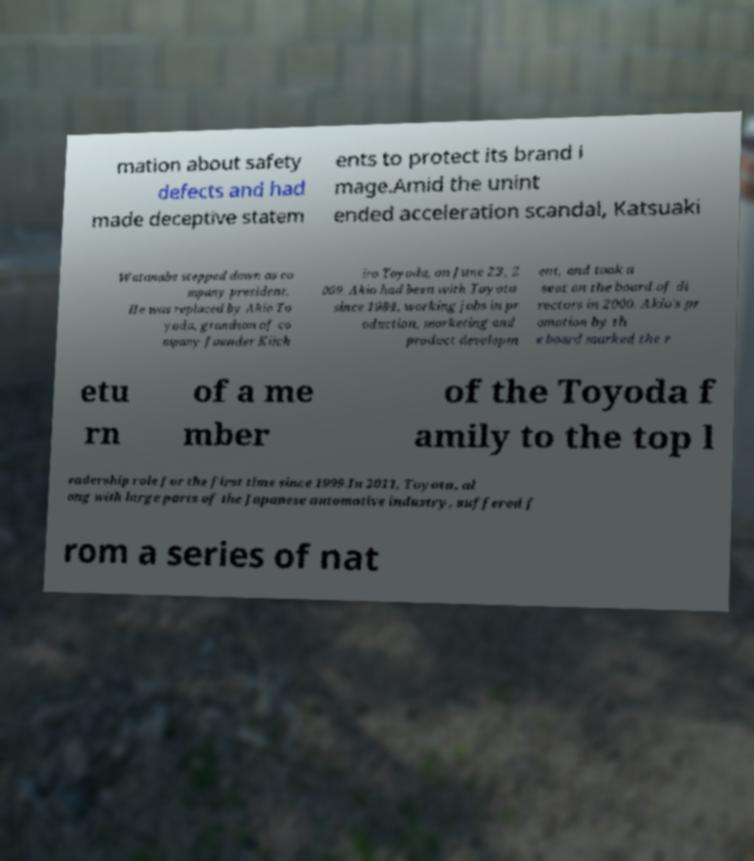Please read and relay the text visible in this image. What does it say? mation about safety defects and had made deceptive statem ents to protect its brand i mage.Amid the unint ended acceleration scandal, Katsuaki Watanabe stepped down as co mpany president. He was replaced by Akio To yoda, grandson of co mpany founder Kiich iro Toyoda, on June 23, 2 009. Akio had been with Toyota since 1984, working jobs in pr oduction, marketing and product developm ent, and took a seat on the board of di rectors in 2000. Akio's pr omotion by th e board marked the r etu rn of a me mber of the Toyoda f amily to the top l eadership role for the first time since 1999.In 2011, Toyota, al ong with large parts of the Japanese automotive industry, suffered f rom a series of nat 